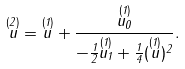<formula> <loc_0><loc_0><loc_500><loc_500>\overset { ( 2 ) } { u } = \overset { ( 1 ) } { u } + \frac { \overset { ( 1 ) } { u _ { 0 } } } { - \frac { 1 } { 2 } \overset { ( 1 ) } { u _ { 1 } } + \frac { 1 } { 4 } ( \overset { ( 1 ) } { u } ) ^ { 2 } } .</formula> 